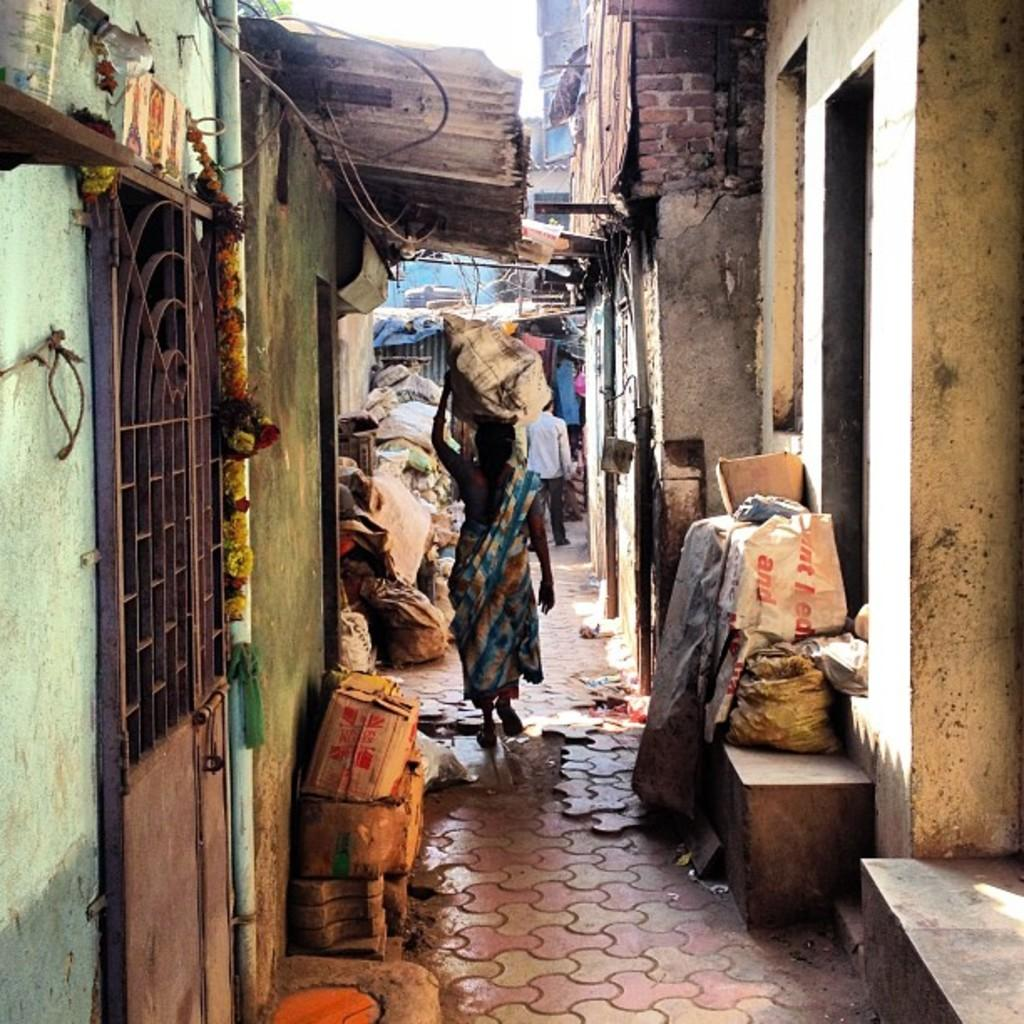What are the people in the image doing? The people in the image are walking on a path. What can be seen on either side of the path? There are houses visible on the sides of the path. Are there any objects placed near the path or houses? Yes, there are objects placed near the path or houses. How many arms are visible in the image? There is no specific mention of arms in the image, so it is impossible to determine the number of arms visible. 